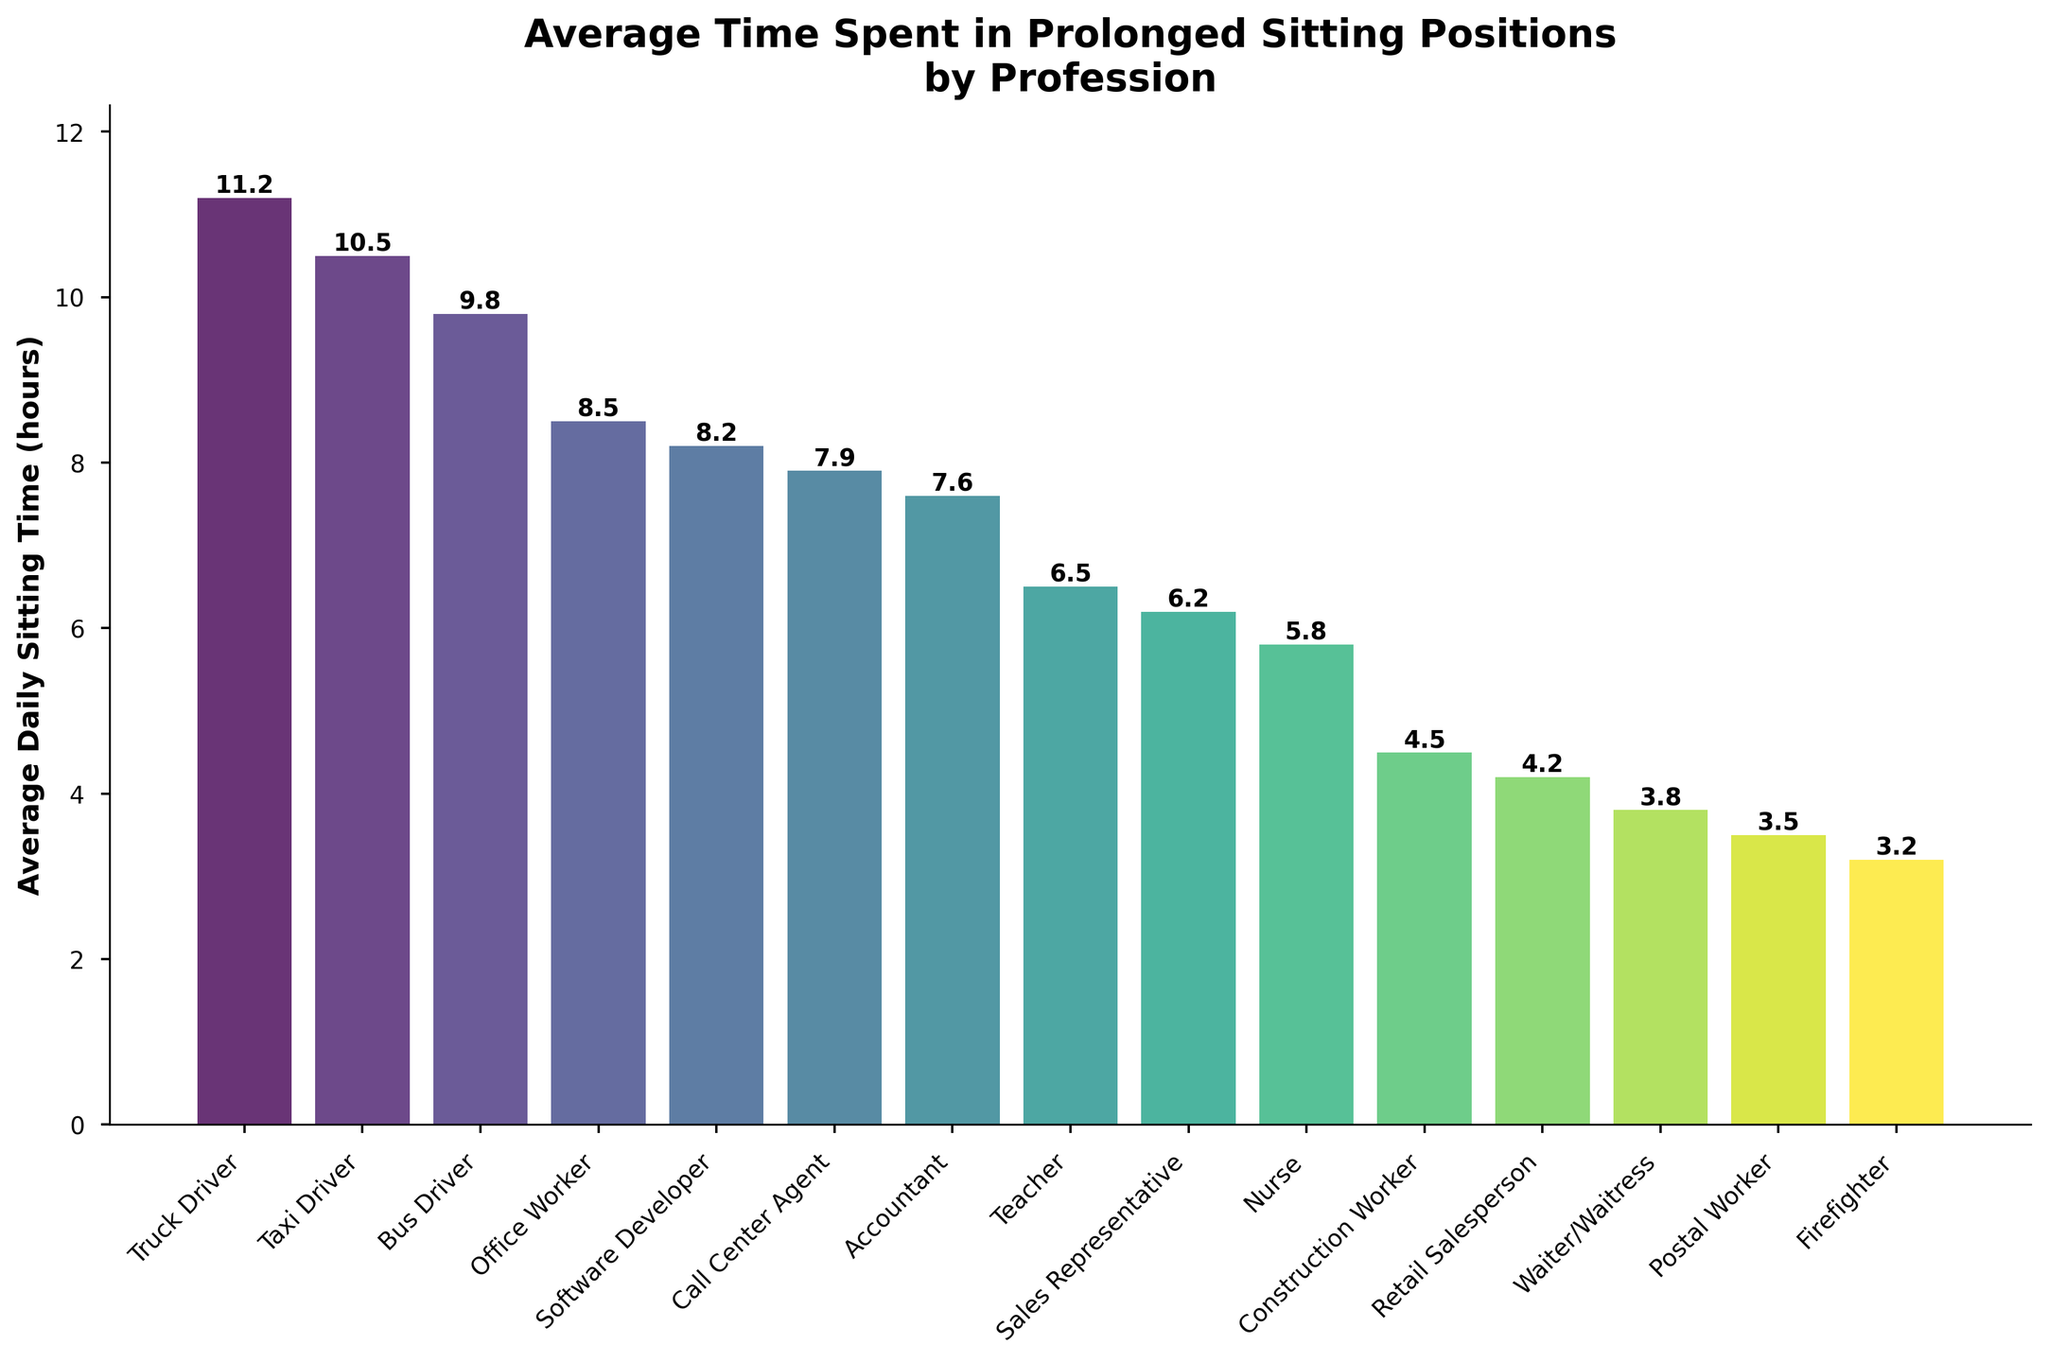Which profession has the highest average daily sitting time? The figure shows the average daily sitting time for various professions. The tallest bar corresponds to the truck driver, indicating it has the highest value.
Answer: Truck Driver Which profession has the lowest average daily sitting time? Observing the shortest bar in the figure, the postal worker has the lowest average sitting time among the listed professions.
Answer: Postal Worker How much longer, on average, do truck drivers sit compared to firefighters? According to the figure, truck drivers sit for an average of 11.2 hours, and firefighters sit for 3.2 hours. The difference can be calculated as 11.2 - 3.2.
Answer: 8.0 hours Which professions have an average daily sitting time greater than 10 hours? The figure indicates that truck drivers and taxi drivers have bars reaching heights above the 10-hour mark.
Answer: Truck Driver, Taxi Driver What's the combined average daily sitting time for office workers, software developers, and call center agents? Summing up the average sitting times for these professions, it is 8.5 (Office Worker) + 8.2 (Software Developer) + 7.9 (Call Center Agent).
Answer: 24.6 hours Compare the sitting times of the office worker and the teacher. Which one sits more on average and by how much? The office worker sits for an average of 8.5 hours while the teacher sits for 6.5 hours. The difference is 8.5 - 6.5.
Answer: Office Worker by 2.0 hours On average, how many hours do driving occupations (truck driver, taxi driver, bus driver) sit daily? Summing the average sitting times for truck driver (11.2), taxi driver (10.5), and bus driver (9.8) and then dividing by 3.
Answer: 10.5 hours What is the median average daily sitting time for all professions shown? Ordering the sitting times: 3.2, 3.5, 3.8, 4.2, 4.5, 5.8, 6.2, 6.5, 7.6, 7.9, 8.2, 8.5, 9.8, 10.5, 11.2. The median is the middle value in this ordered list.
Answer: 6.5 hours What is the difference in average sitting time between the profession with the highest and the lowest values? The highest average sitting time is 11.2 hours (Truck Driver), and the lowest is 3.2 hours (Postal Worker). Their difference is 11.2 - 3.2.
Answer: 8.0 hours 